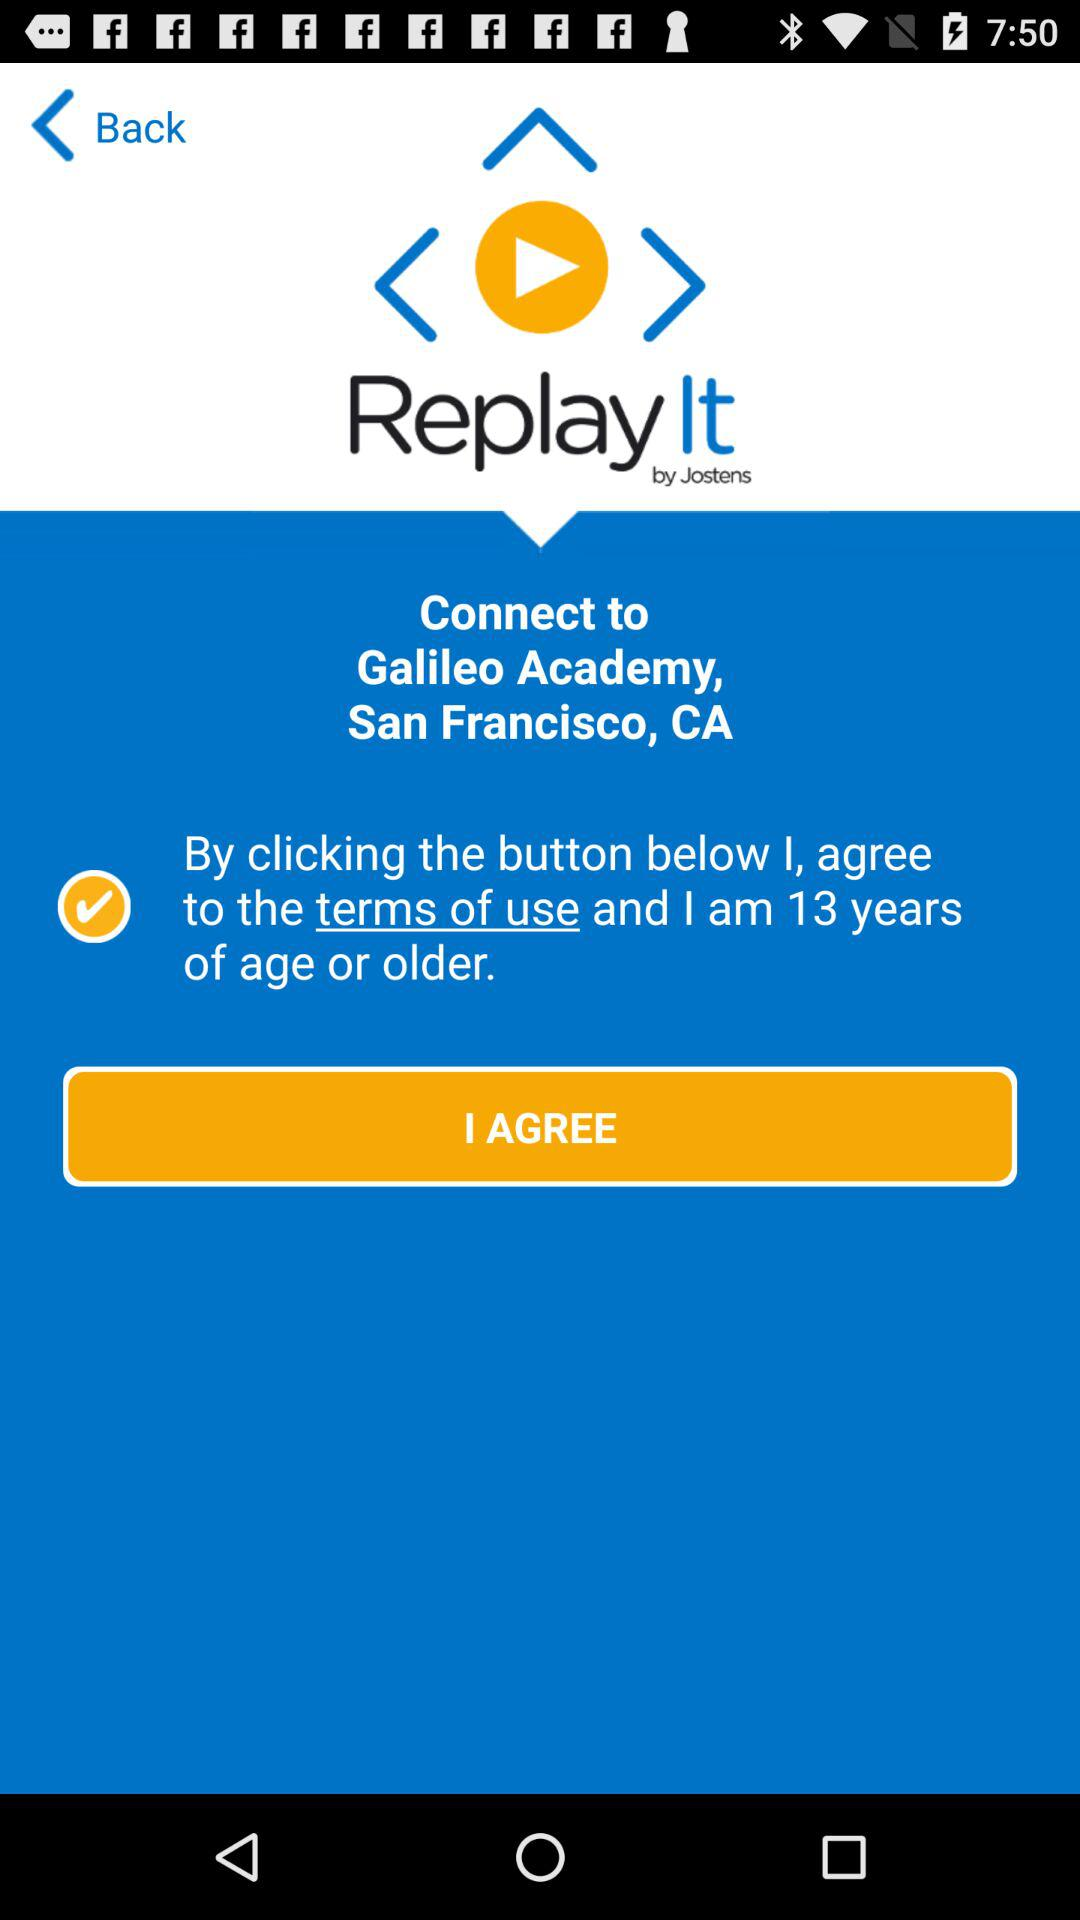What is the name of the application? The name of the application is "Replay It". 